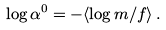Convert formula to latex. <formula><loc_0><loc_0><loc_500><loc_500>\log \alpha ^ { 0 } = - \langle \log m / f \rangle \, .</formula> 